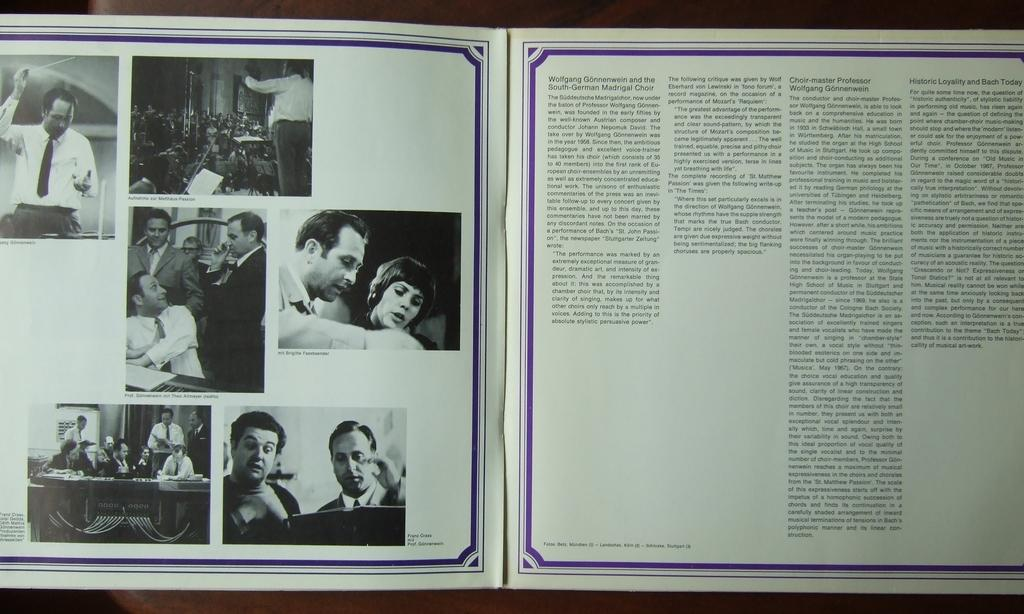<image>
Write a terse but informative summary of the picture. a book with pictures and text about Wolfgang Gonnenwein 